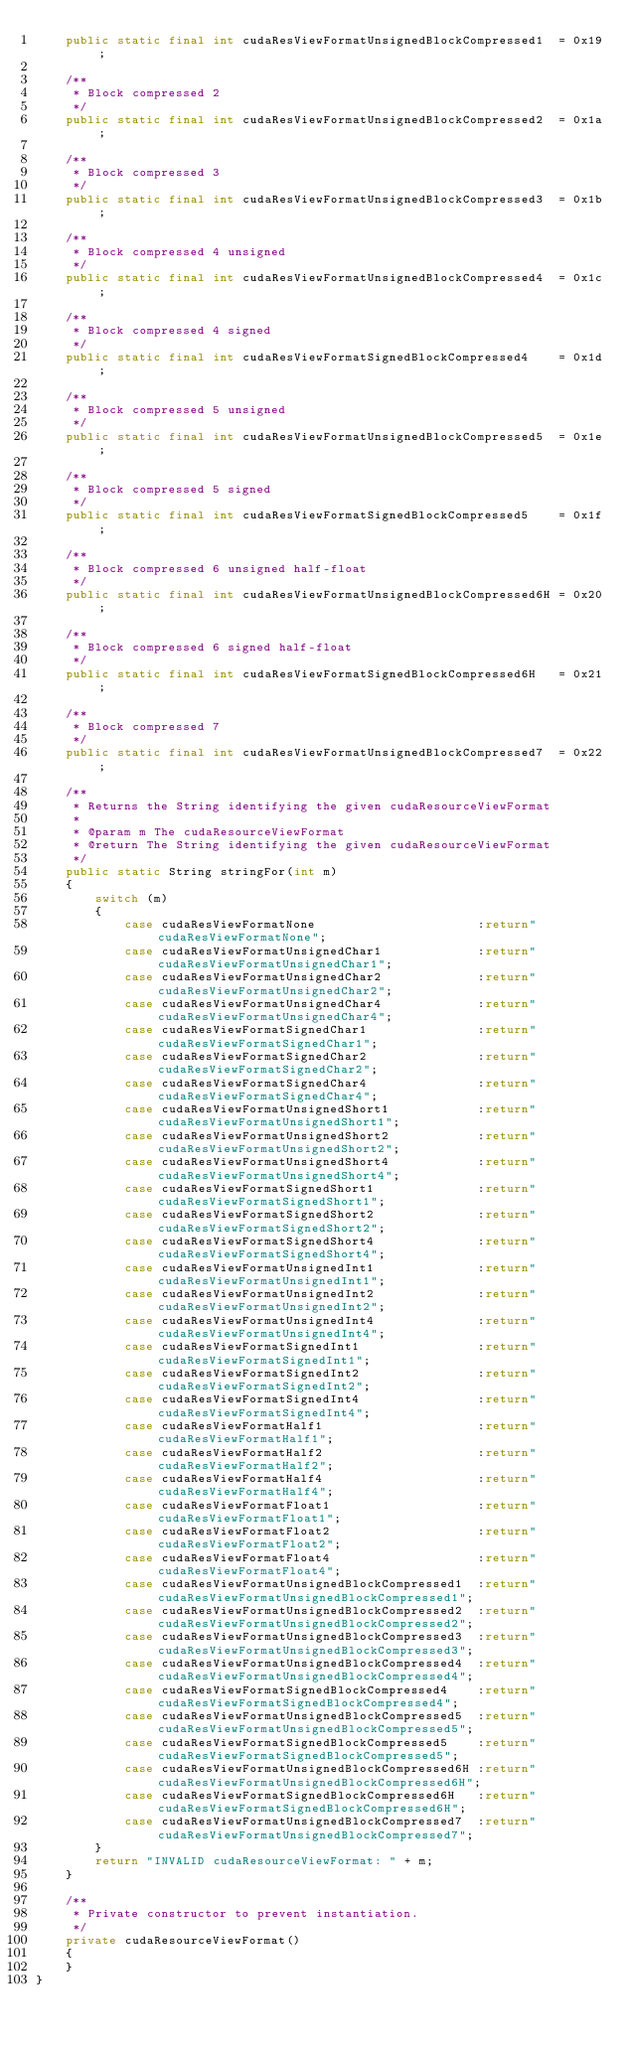<code> <loc_0><loc_0><loc_500><loc_500><_Java_>    public static final int cudaResViewFormatUnsignedBlockCompressed1  = 0x19;
    
    /**
     * Block compressed 2 
     */
    public static final int cudaResViewFormatUnsignedBlockCompressed2  = 0x1a;
    
    /**
     * Block compressed 3 
     */
    public static final int cudaResViewFormatUnsignedBlockCompressed3  = 0x1b;
    
    /**
     * Block compressed 4 unsigned 
     */
    public static final int cudaResViewFormatUnsignedBlockCompressed4  = 0x1c;
    
    /**
     * Block compressed 4 signed 
     */
    public static final int cudaResViewFormatSignedBlockCompressed4    = 0x1d;
    
    /**
     * Block compressed 5 unsigned 
     */
    public static final int cudaResViewFormatUnsignedBlockCompressed5  = 0x1e;
    
    /**
     * Block compressed 5 signed 
     */
    public static final int cudaResViewFormatSignedBlockCompressed5    = 0x1f;
    
    /**
     * Block compressed 6 unsigned half-float 
     */
    public static final int cudaResViewFormatUnsignedBlockCompressed6H = 0x20;
    
    /**
     * Block compressed 6 signed half-float 
     */
    public static final int cudaResViewFormatSignedBlockCompressed6H   = 0x21;
    
    /**
     * Block compressed 7 
     */
    public static final int cudaResViewFormatUnsignedBlockCompressed7  = 0x22;

    /**
     * Returns the String identifying the given cudaResourceViewFormat
     * 
     * @param m The cudaResourceViewFormat
     * @return The String identifying the given cudaResourceViewFormat
     */
    public static String stringFor(int m)
    {
        switch (m)
        {
            case cudaResViewFormatNone                      :return"cudaResViewFormatNone";
            case cudaResViewFormatUnsignedChar1             :return"cudaResViewFormatUnsignedChar1";
            case cudaResViewFormatUnsignedChar2             :return"cudaResViewFormatUnsignedChar2";
            case cudaResViewFormatUnsignedChar4             :return"cudaResViewFormatUnsignedChar4";
            case cudaResViewFormatSignedChar1               :return"cudaResViewFormatSignedChar1";
            case cudaResViewFormatSignedChar2               :return"cudaResViewFormatSignedChar2";
            case cudaResViewFormatSignedChar4               :return"cudaResViewFormatSignedChar4";
            case cudaResViewFormatUnsignedShort1            :return"cudaResViewFormatUnsignedShort1";
            case cudaResViewFormatUnsignedShort2            :return"cudaResViewFormatUnsignedShort2";
            case cudaResViewFormatUnsignedShort4            :return"cudaResViewFormatUnsignedShort4";
            case cudaResViewFormatSignedShort1              :return"cudaResViewFormatSignedShort1";
            case cudaResViewFormatSignedShort2              :return"cudaResViewFormatSignedShort2";
            case cudaResViewFormatSignedShort4              :return"cudaResViewFormatSignedShort4";
            case cudaResViewFormatUnsignedInt1              :return"cudaResViewFormatUnsignedInt1";
            case cudaResViewFormatUnsignedInt2              :return"cudaResViewFormatUnsignedInt2";
            case cudaResViewFormatUnsignedInt4              :return"cudaResViewFormatUnsignedInt4";
            case cudaResViewFormatSignedInt1                :return"cudaResViewFormatSignedInt1";
            case cudaResViewFormatSignedInt2                :return"cudaResViewFormatSignedInt2";
            case cudaResViewFormatSignedInt4                :return"cudaResViewFormatSignedInt4";
            case cudaResViewFormatHalf1                     :return"cudaResViewFormatHalf1";
            case cudaResViewFormatHalf2                     :return"cudaResViewFormatHalf2";
            case cudaResViewFormatHalf4                     :return"cudaResViewFormatHalf4";
            case cudaResViewFormatFloat1                    :return"cudaResViewFormatFloat1";
            case cudaResViewFormatFloat2                    :return"cudaResViewFormatFloat2";
            case cudaResViewFormatFloat4                    :return"cudaResViewFormatFloat4";
            case cudaResViewFormatUnsignedBlockCompressed1  :return"cudaResViewFormatUnsignedBlockCompressed1";
            case cudaResViewFormatUnsignedBlockCompressed2  :return"cudaResViewFormatUnsignedBlockCompressed2";
            case cudaResViewFormatUnsignedBlockCompressed3  :return"cudaResViewFormatUnsignedBlockCompressed3";
            case cudaResViewFormatUnsignedBlockCompressed4  :return"cudaResViewFormatUnsignedBlockCompressed4";
            case cudaResViewFormatSignedBlockCompressed4    :return"cudaResViewFormatSignedBlockCompressed4";
            case cudaResViewFormatUnsignedBlockCompressed5  :return"cudaResViewFormatUnsignedBlockCompressed5";
            case cudaResViewFormatSignedBlockCompressed5    :return"cudaResViewFormatSignedBlockCompressed5";
            case cudaResViewFormatUnsignedBlockCompressed6H :return"cudaResViewFormatUnsignedBlockCompressed6H";
            case cudaResViewFormatSignedBlockCompressed6H   :return"cudaResViewFormatSignedBlockCompressed6H";
            case cudaResViewFormatUnsignedBlockCompressed7  :return"cudaResViewFormatUnsignedBlockCompressed7";
        }
        return "INVALID cudaResourceViewFormat: " + m;
    }
    
    /**
     * Private constructor to prevent instantiation.
     */
    private cudaResourceViewFormat()
    {
    }
}
</code> 